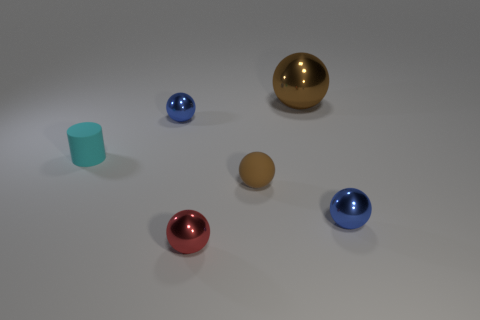Is the color of the large metal object the same as the small rubber cylinder?
Provide a succinct answer. No. Is the material of the big sphere the same as the tiny ball that is on the left side of the small red object?
Your answer should be compact. Yes. What color is the metal thing that is behind the tiny blue thing behind the blue metal ball that is in front of the small cyan thing?
Your answer should be compact. Brown. Is there anything else that is the same size as the matte sphere?
Your answer should be very brief. Yes. There is a big sphere; is its color the same as the tiny object that is on the right side of the brown rubber ball?
Your response must be concise. No. What is the color of the cylinder?
Give a very brief answer. Cyan. What is the shape of the brown object that is behind the blue metallic thing behind the object to the right of the large brown object?
Offer a terse response. Sphere. What number of other objects are there of the same color as the large metal sphere?
Your answer should be compact. 1. Is the number of tiny cyan matte cylinders that are in front of the red shiny object greater than the number of brown metallic spheres that are to the left of the big shiny sphere?
Ensure brevity in your answer.  No. Are there any tiny red objects to the right of the small rubber sphere?
Your response must be concise. No. 